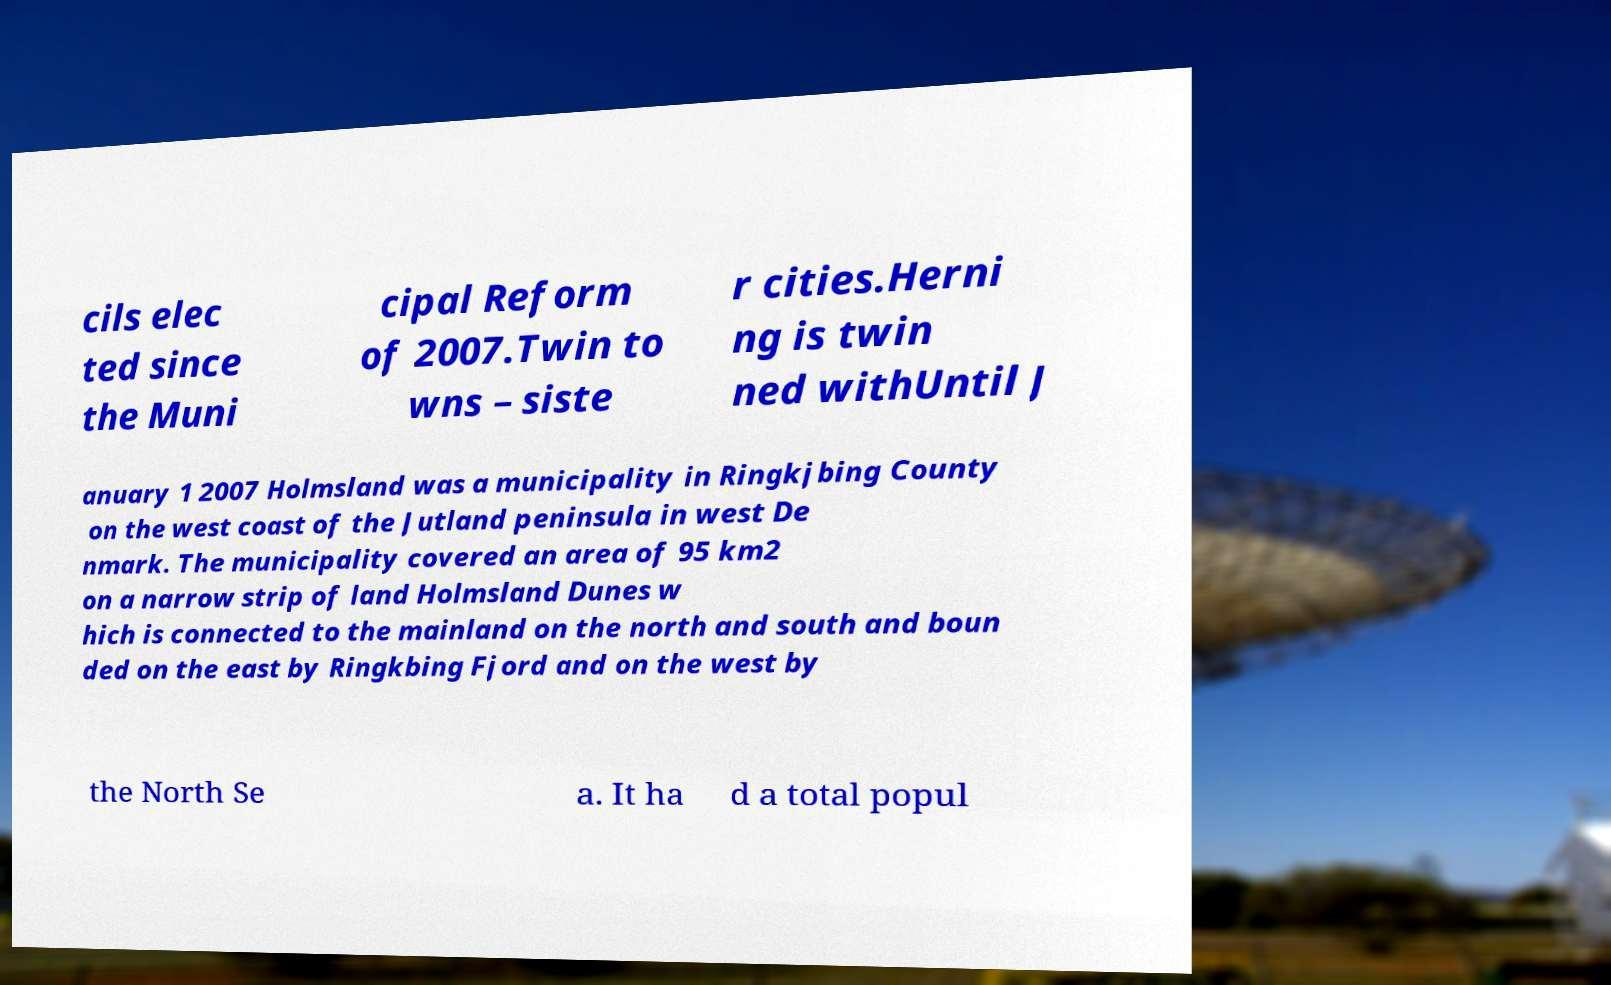Could you assist in decoding the text presented in this image and type it out clearly? cils elec ted since the Muni cipal Reform of 2007.Twin to wns – siste r cities.Herni ng is twin ned withUntil J anuary 1 2007 Holmsland was a municipality in Ringkjbing County on the west coast of the Jutland peninsula in west De nmark. The municipality covered an area of 95 km2 on a narrow strip of land Holmsland Dunes w hich is connected to the mainland on the north and south and boun ded on the east by Ringkbing Fjord and on the west by the North Se a. It ha d a total popul 